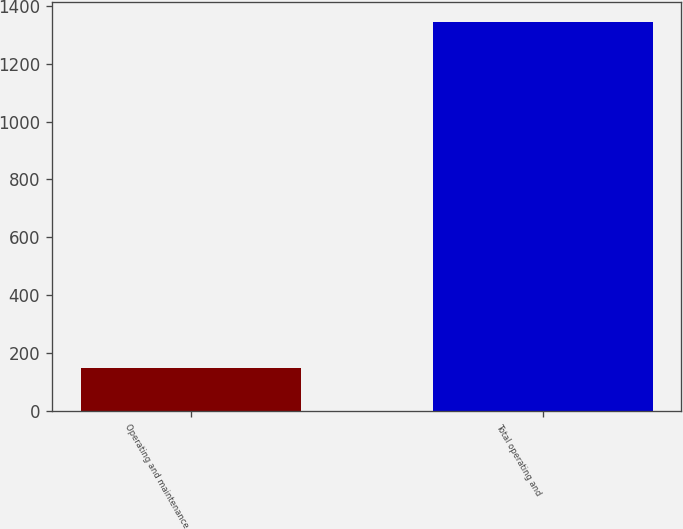Convert chart to OTSL. <chart><loc_0><loc_0><loc_500><loc_500><bar_chart><fcel>Operating and maintenance<fcel>Total operating and<nl><fcel>147<fcel>1345<nl></chart> 